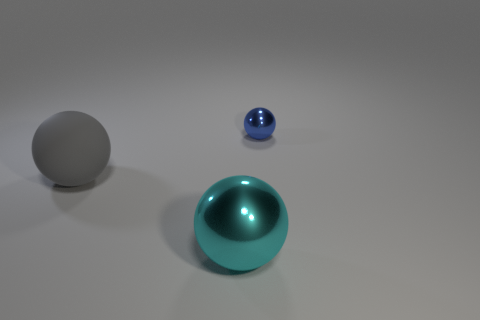Subtract all shiny balls. How many balls are left? 1 Subtract all gray spheres. How many spheres are left? 2 Add 1 tiny brown objects. How many objects exist? 4 Add 1 blue shiny balls. How many blue shiny balls exist? 2 Subtract 0 blue cylinders. How many objects are left? 3 Subtract 3 balls. How many balls are left? 0 Subtract all yellow balls. Subtract all red cubes. How many balls are left? 3 Subtract all red cylinders. How many green spheres are left? 0 Subtract all gray rubber objects. Subtract all gray matte objects. How many objects are left? 1 Add 1 gray balls. How many gray balls are left? 2 